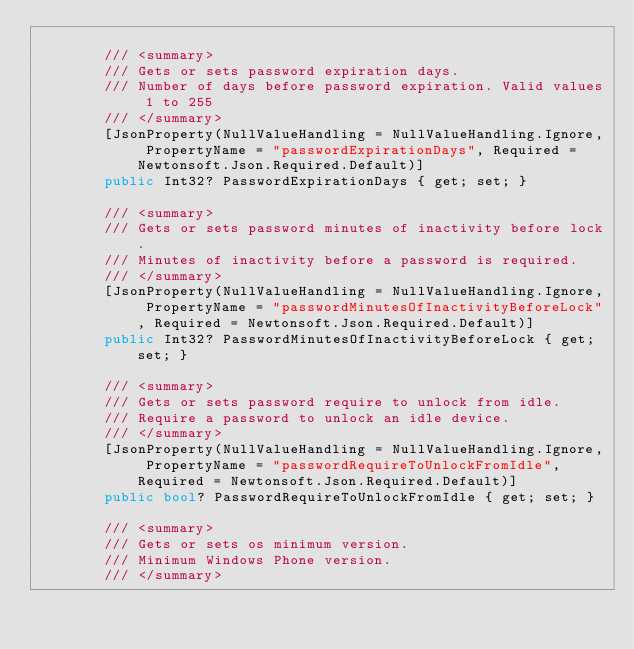<code> <loc_0><loc_0><loc_500><loc_500><_C#_>    
        /// <summary>
        /// Gets or sets password expiration days.
        /// Number of days before password expiration. Valid values 1 to 255
        /// </summary>
        [JsonProperty(NullValueHandling = NullValueHandling.Ignore, PropertyName = "passwordExpirationDays", Required = Newtonsoft.Json.Required.Default)]
        public Int32? PasswordExpirationDays { get; set; }
    
        /// <summary>
        /// Gets or sets password minutes of inactivity before lock.
        /// Minutes of inactivity before a password is required.
        /// </summary>
        [JsonProperty(NullValueHandling = NullValueHandling.Ignore, PropertyName = "passwordMinutesOfInactivityBeforeLock", Required = Newtonsoft.Json.Required.Default)]
        public Int32? PasswordMinutesOfInactivityBeforeLock { get; set; }
    
        /// <summary>
        /// Gets or sets password require to unlock from idle.
        /// Require a password to unlock an idle device.
        /// </summary>
        [JsonProperty(NullValueHandling = NullValueHandling.Ignore, PropertyName = "passwordRequireToUnlockFromIdle", Required = Newtonsoft.Json.Required.Default)]
        public bool? PasswordRequireToUnlockFromIdle { get; set; }
    
        /// <summary>
        /// Gets or sets os minimum version.
        /// Minimum Windows Phone version.
        /// </summary></code> 